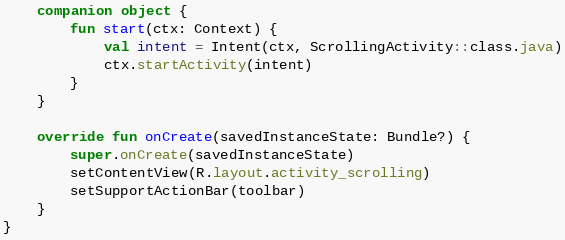Convert code to text. <code><loc_0><loc_0><loc_500><loc_500><_Kotlin_>    companion object {
        fun start(ctx: Context) {
            val intent = Intent(ctx, ScrollingActivity::class.java)
            ctx.startActivity(intent)
        }
    }

    override fun onCreate(savedInstanceState: Bundle?) {
        super.onCreate(savedInstanceState)
        setContentView(R.layout.activity_scrolling)
        setSupportActionBar(toolbar)
    }
}
</code> 